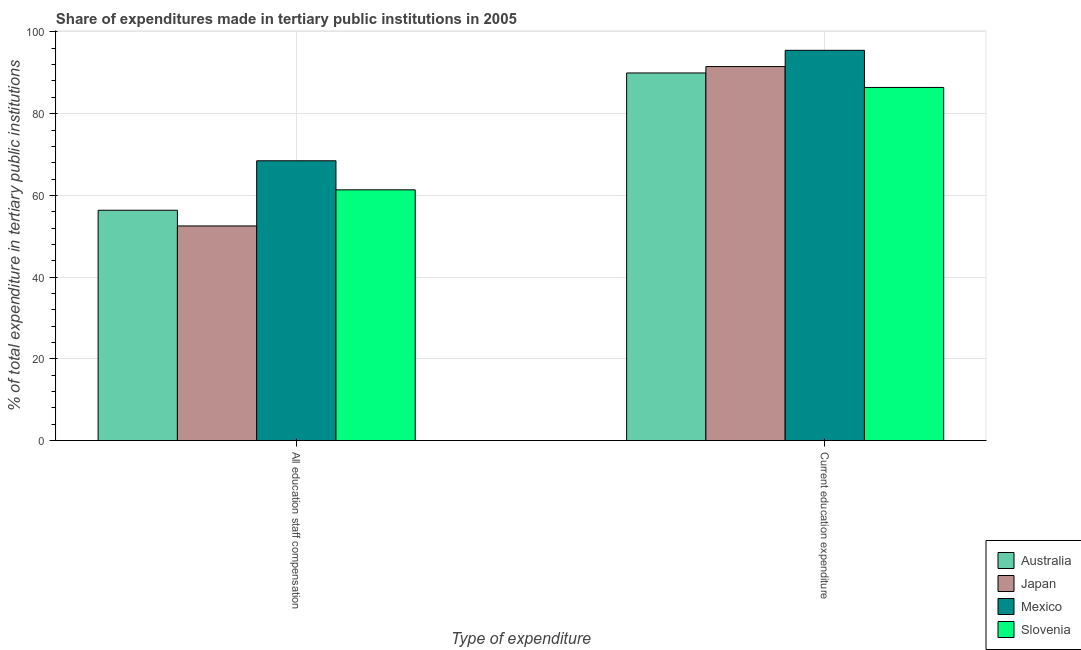Are the number of bars per tick equal to the number of legend labels?
Give a very brief answer. Yes. Are the number of bars on each tick of the X-axis equal?
Provide a short and direct response. Yes. What is the label of the 2nd group of bars from the left?
Offer a very short reply. Current education expenditure. What is the expenditure in education in Slovenia?
Your response must be concise. 86.42. Across all countries, what is the maximum expenditure in staff compensation?
Give a very brief answer. 68.47. Across all countries, what is the minimum expenditure in staff compensation?
Offer a very short reply. 52.53. In which country was the expenditure in education minimum?
Your answer should be very brief. Slovenia. What is the total expenditure in education in the graph?
Provide a short and direct response. 363.41. What is the difference between the expenditure in staff compensation in Mexico and that in Australia?
Ensure brevity in your answer.  12.11. What is the difference between the expenditure in education in Japan and the expenditure in staff compensation in Slovenia?
Keep it short and to the point. 30.17. What is the average expenditure in education per country?
Provide a short and direct response. 90.85. What is the difference between the expenditure in education and expenditure in staff compensation in Japan?
Keep it short and to the point. 39. In how many countries, is the expenditure in education greater than 20 %?
Provide a succinct answer. 4. What is the ratio of the expenditure in education in Slovenia to that in Australia?
Your response must be concise. 0.96. Is the expenditure in staff compensation in Slovenia less than that in Japan?
Your answer should be compact. No. In how many countries, is the expenditure in staff compensation greater than the average expenditure in staff compensation taken over all countries?
Provide a short and direct response. 2. What does the 3rd bar from the left in All education staff compensation represents?
Your answer should be compact. Mexico. What does the 2nd bar from the right in All education staff compensation represents?
Your answer should be compact. Mexico. Are all the bars in the graph horizontal?
Provide a short and direct response. No. What is the difference between two consecutive major ticks on the Y-axis?
Your answer should be compact. 20. Are the values on the major ticks of Y-axis written in scientific E-notation?
Make the answer very short. No. How many legend labels are there?
Provide a succinct answer. 4. How are the legend labels stacked?
Your answer should be very brief. Vertical. What is the title of the graph?
Make the answer very short. Share of expenditures made in tertiary public institutions in 2005. What is the label or title of the X-axis?
Keep it short and to the point. Type of expenditure. What is the label or title of the Y-axis?
Offer a terse response. % of total expenditure in tertiary public institutions. What is the % of total expenditure in tertiary public institutions of Australia in All education staff compensation?
Your response must be concise. 56.37. What is the % of total expenditure in tertiary public institutions of Japan in All education staff compensation?
Ensure brevity in your answer.  52.53. What is the % of total expenditure in tertiary public institutions of Mexico in All education staff compensation?
Keep it short and to the point. 68.47. What is the % of total expenditure in tertiary public institutions in Slovenia in All education staff compensation?
Give a very brief answer. 61.36. What is the % of total expenditure in tertiary public institutions in Australia in Current education expenditure?
Provide a succinct answer. 89.96. What is the % of total expenditure in tertiary public institutions of Japan in Current education expenditure?
Ensure brevity in your answer.  91.53. What is the % of total expenditure in tertiary public institutions in Mexico in Current education expenditure?
Provide a short and direct response. 95.5. What is the % of total expenditure in tertiary public institutions in Slovenia in Current education expenditure?
Give a very brief answer. 86.42. Across all Type of expenditure, what is the maximum % of total expenditure in tertiary public institutions in Australia?
Provide a succinct answer. 89.96. Across all Type of expenditure, what is the maximum % of total expenditure in tertiary public institutions of Japan?
Make the answer very short. 91.53. Across all Type of expenditure, what is the maximum % of total expenditure in tertiary public institutions of Mexico?
Your response must be concise. 95.5. Across all Type of expenditure, what is the maximum % of total expenditure in tertiary public institutions of Slovenia?
Your answer should be compact. 86.42. Across all Type of expenditure, what is the minimum % of total expenditure in tertiary public institutions in Australia?
Your answer should be very brief. 56.37. Across all Type of expenditure, what is the minimum % of total expenditure in tertiary public institutions in Japan?
Ensure brevity in your answer.  52.53. Across all Type of expenditure, what is the minimum % of total expenditure in tertiary public institutions of Mexico?
Your answer should be compact. 68.47. Across all Type of expenditure, what is the minimum % of total expenditure in tertiary public institutions in Slovenia?
Your answer should be compact. 61.36. What is the total % of total expenditure in tertiary public institutions of Australia in the graph?
Provide a succinct answer. 146.33. What is the total % of total expenditure in tertiary public institutions of Japan in the graph?
Provide a succinct answer. 144.06. What is the total % of total expenditure in tertiary public institutions of Mexico in the graph?
Offer a very short reply. 163.97. What is the total % of total expenditure in tertiary public institutions of Slovenia in the graph?
Your response must be concise. 147.78. What is the difference between the % of total expenditure in tertiary public institutions in Australia in All education staff compensation and that in Current education expenditure?
Your answer should be compact. -33.6. What is the difference between the % of total expenditure in tertiary public institutions of Japan in All education staff compensation and that in Current education expenditure?
Offer a very short reply. -39. What is the difference between the % of total expenditure in tertiary public institutions of Mexico in All education staff compensation and that in Current education expenditure?
Your response must be concise. -27.03. What is the difference between the % of total expenditure in tertiary public institutions of Slovenia in All education staff compensation and that in Current education expenditure?
Provide a short and direct response. -25.06. What is the difference between the % of total expenditure in tertiary public institutions in Australia in All education staff compensation and the % of total expenditure in tertiary public institutions in Japan in Current education expenditure?
Your answer should be compact. -35.16. What is the difference between the % of total expenditure in tertiary public institutions of Australia in All education staff compensation and the % of total expenditure in tertiary public institutions of Mexico in Current education expenditure?
Your response must be concise. -39.13. What is the difference between the % of total expenditure in tertiary public institutions of Australia in All education staff compensation and the % of total expenditure in tertiary public institutions of Slovenia in Current education expenditure?
Your response must be concise. -30.05. What is the difference between the % of total expenditure in tertiary public institutions of Japan in All education staff compensation and the % of total expenditure in tertiary public institutions of Mexico in Current education expenditure?
Provide a succinct answer. -42.97. What is the difference between the % of total expenditure in tertiary public institutions of Japan in All education staff compensation and the % of total expenditure in tertiary public institutions of Slovenia in Current education expenditure?
Make the answer very short. -33.89. What is the difference between the % of total expenditure in tertiary public institutions in Mexico in All education staff compensation and the % of total expenditure in tertiary public institutions in Slovenia in Current education expenditure?
Your answer should be compact. -17.95. What is the average % of total expenditure in tertiary public institutions of Australia per Type of expenditure?
Offer a terse response. 73.16. What is the average % of total expenditure in tertiary public institutions in Japan per Type of expenditure?
Make the answer very short. 72.03. What is the average % of total expenditure in tertiary public institutions in Mexico per Type of expenditure?
Give a very brief answer. 81.99. What is the average % of total expenditure in tertiary public institutions of Slovenia per Type of expenditure?
Your answer should be compact. 73.89. What is the difference between the % of total expenditure in tertiary public institutions of Australia and % of total expenditure in tertiary public institutions of Japan in All education staff compensation?
Give a very brief answer. 3.84. What is the difference between the % of total expenditure in tertiary public institutions of Australia and % of total expenditure in tertiary public institutions of Mexico in All education staff compensation?
Give a very brief answer. -12.11. What is the difference between the % of total expenditure in tertiary public institutions in Australia and % of total expenditure in tertiary public institutions in Slovenia in All education staff compensation?
Give a very brief answer. -4.99. What is the difference between the % of total expenditure in tertiary public institutions of Japan and % of total expenditure in tertiary public institutions of Mexico in All education staff compensation?
Ensure brevity in your answer.  -15.95. What is the difference between the % of total expenditure in tertiary public institutions of Japan and % of total expenditure in tertiary public institutions of Slovenia in All education staff compensation?
Provide a succinct answer. -8.83. What is the difference between the % of total expenditure in tertiary public institutions of Mexico and % of total expenditure in tertiary public institutions of Slovenia in All education staff compensation?
Make the answer very short. 7.11. What is the difference between the % of total expenditure in tertiary public institutions of Australia and % of total expenditure in tertiary public institutions of Japan in Current education expenditure?
Your response must be concise. -1.57. What is the difference between the % of total expenditure in tertiary public institutions of Australia and % of total expenditure in tertiary public institutions of Mexico in Current education expenditure?
Give a very brief answer. -5.54. What is the difference between the % of total expenditure in tertiary public institutions of Australia and % of total expenditure in tertiary public institutions of Slovenia in Current education expenditure?
Give a very brief answer. 3.54. What is the difference between the % of total expenditure in tertiary public institutions in Japan and % of total expenditure in tertiary public institutions in Mexico in Current education expenditure?
Your answer should be very brief. -3.97. What is the difference between the % of total expenditure in tertiary public institutions in Japan and % of total expenditure in tertiary public institutions in Slovenia in Current education expenditure?
Offer a terse response. 5.11. What is the difference between the % of total expenditure in tertiary public institutions of Mexico and % of total expenditure in tertiary public institutions of Slovenia in Current education expenditure?
Ensure brevity in your answer.  9.08. What is the ratio of the % of total expenditure in tertiary public institutions in Australia in All education staff compensation to that in Current education expenditure?
Your answer should be very brief. 0.63. What is the ratio of the % of total expenditure in tertiary public institutions of Japan in All education staff compensation to that in Current education expenditure?
Make the answer very short. 0.57. What is the ratio of the % of total expenditure in tertiary public institutions of Mexico in All education staff compensation to that in Current education expenditure?
Provide a succinct answer. 0.72. What is the ratio of the % of total expenditure in tertiary public institutions of Slovenia in All education staff compensation to that in Current education expenditure?
Give a very brief answer. 0.71. What is the difference between the highest and the second highest % of total expenditure in tertiary public institutions of Australia?
Your answer should be compact. 33.6. What is the difference between the highest and the second highest % of total expenditure in tertiary public institutions in Japan?
Make the answer very short. 39. What is the difference between the highest and the second highest % of total expenditure in tertiary public institutions in Mexico?
Your answer should be compact. 27.03. What is the difference between the highest and the second highest % of total expenditure in tertiary public institutions of Slovenia?
Provide a short and direct response. 25.06. What is the difference between the highest and the lowest % of total expenditure in tertiary public institutions in Australia?
Offer a very short reply. 33.6. What is the difference between the highest and the lowest % of total expenditure in tertiary public institutions in Japan?
Offer a terse response. 39. What is the difference between the highest and the lowest % of total expenditure in tertiary public institutions in Mexico?
Your answer should be very brief. 27.03. What is the difference between the highest and the lowest % of total expenditure in tertiary public institutions in Slovenia?
Provide a succinct answer. 25.06. 